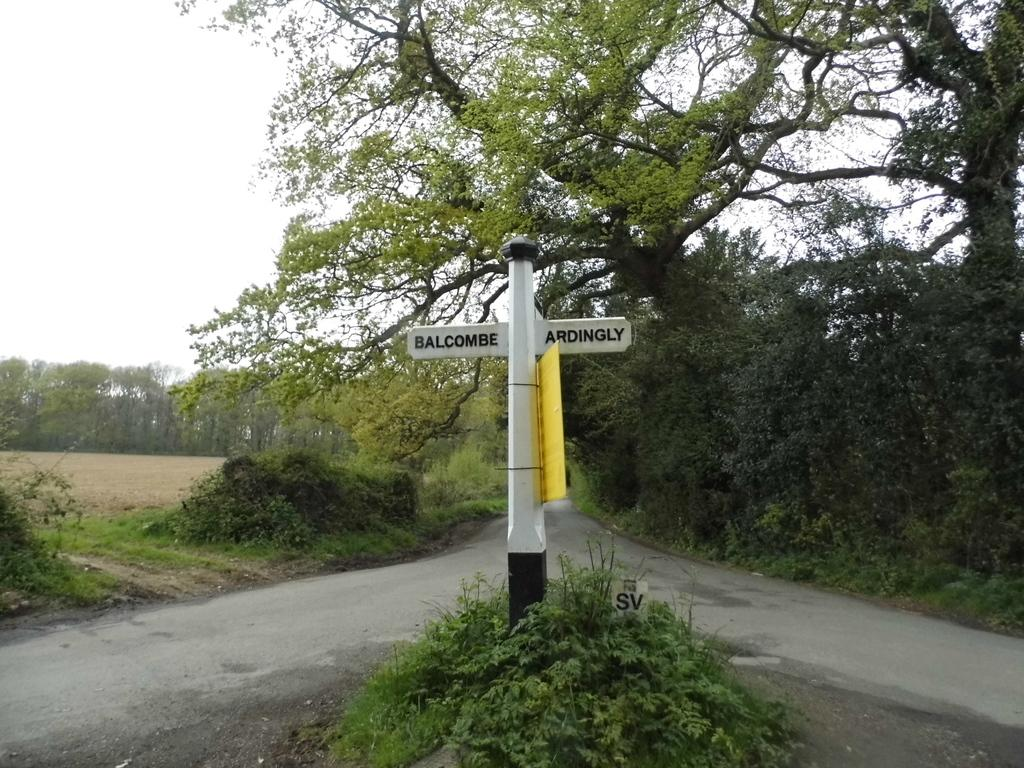What is the color of the pole in the image? The pole in the image is white-colored. What is attached to the pole? There is a yellow-colored board attached to the pole. What type of vegetation is present in the image? There is a plant in the image. What type of man-made structure is visible in the image? The road is visible in the image. What type of natural scenery is visible in the image? There are trees in the image and in the background of the image. What part of the natural environment is visible in the background of the image? The sky is visible in the background of the image. How many boats can be seen in the image? There are no boats present in the image. 